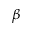<formula> <loc_0><loc_0><loc_500><loc_500>\beta</formula> 